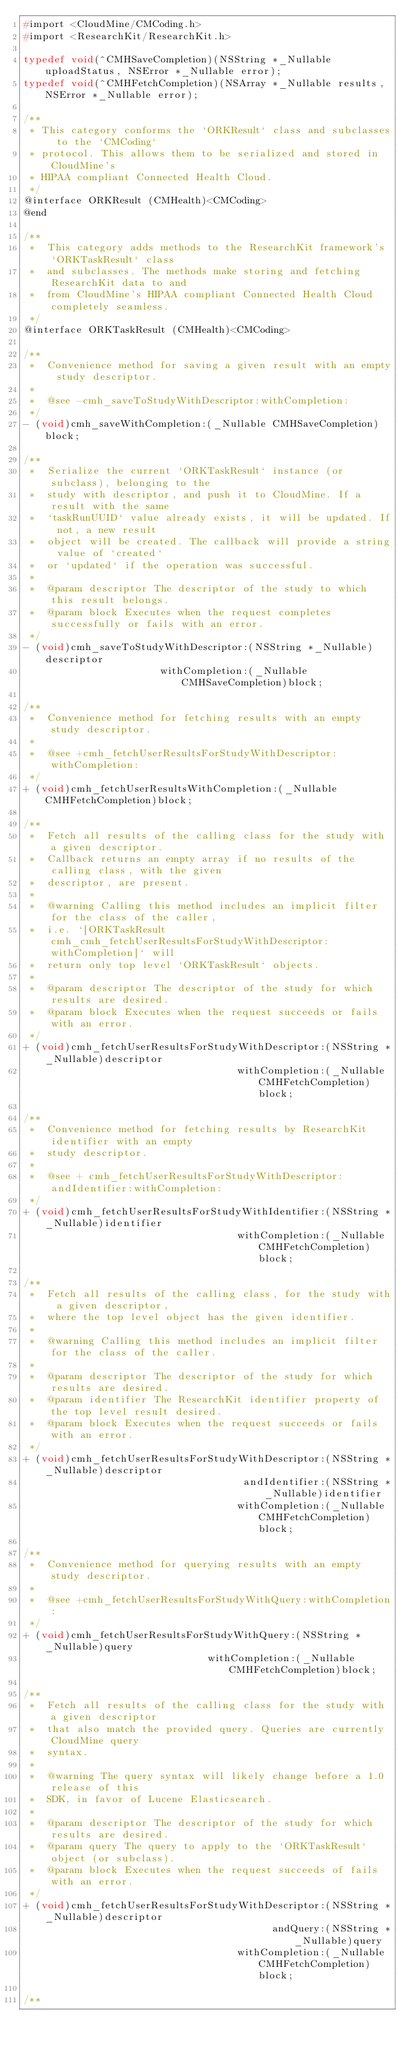Convert code to text. <code><loc_0><loc_0><loc_500><loc_500><_C_>#import <CloudMine/CMCoding.h>
#import <ResearchKit/ResearchKit.h>

typedef void(^CMHSaveCompletion)(NSString *_Nullable uploadStatus, NSError *_Nullable error);
typedef void(^CMHFetchCompletion)(NSArray *_Nullable results, NSError *_Nullable error);

/**
 * This category conforms the `ORKResult` class and subclasses to the `CMCoding`
 * protocol. This allows them to be serialized and stored in CloudMine's
 * HIPAA compliant Connected Health Cloud.
 */
@interface ORKResult (CMHealth)<CMCoding>
@end

/**
 *  This category adds methods to the ResearchKit framework's `ORKTaskResult` class 
 *  and subclasses. The methods make storing and fetching ResearchKit data to and
 *  from CloudMine's HIPAA compliant Connected Health Cloud completely seamless.
 */
@interface ORKTaskResult (CMHealth)<CMCoding>

/**
 *  Convenience method for saving a given result with an empty study descriptor.
 *
 *  @see -cmh_saveToStudyWithDescriptor:withCompletion:
 */
- (void)cmh_saveWithCompletion:(_Nullable CMHSaveCompletion)block;

/**
 *  Serialize the current `ORKTaskResult` instance (or subclass), belonging to the
 *  study with descriptor, and push it to CloudMine. If a result with the same
 *  `taskRunUUID` value already exists, it will be updated. If not, a new result
 *  object will be created. The callback will provide a string value of `created`
 *  or `updated` if the operation was successful.
 *
 *  @param descriptor The descriptor of the study to which this result belongs.
 *  @param block Executes when the request completes successfully or fails with an error.
 */
- (void)cmh_saveToStudyWithDescriptor:(NSString *_Nullable)descriptor
                       withCompletion:(_Nullable CMHSaveCompletion)block;

/**
 *  Convenience method for fetching results with an empty study descriptor.
 *
 *  @see +cmh_fetchUserResultsForStudyWithDescriptor:withCompletion:
 */
+ (void)cmh_fetchUserResultsWithCompletion:(_Nullable CMHFetchCompletion)block;

/**
 *  Fetch all results of the calling class for the study with a given descriptor.
 *  Callback returns an empty array if no results of the calling class, with the given
 *  descriptor, are present.
 *
 *  @warning Calling this method includes an implicit filter for the class of the caller,
 *  i.e. `[ORKTaskResult cmh_cmh_fetchUserResultsForStudyWithDescriptor:withCompletion]` will
 *  return only top level `ORKTaskResult` objects.
 *
 *  @param descriptor The descriptor of the study for which results are desired.
 *  @param block Executes when the request succeeds or fails with an error.
 */
+ (void)cmh_fetchUserResultsForStudyWithDescriptor:(NSString *_Nullable)descriptor
                                    withCompletion:(_Nullable CMHFetchCompletion)block;

/**
 *  Convenience method for fetching results by ResearchKit identifier with an empty
 *  study descriptor.
 *
 *  @see + cmh_fetchUserResultsForStudyWithDescriptor:andIdentifier:withCompletion:
 */
+ (void)cmh_fetchUserResultsForStudyWithIdentifier:(NSString *_Nullable)identifier
                                    withCompletion:(_Nullable CMHFetchCompletion)block;

/**
 *  Fetch all results of the calling class, for the study with a given descriptor,
 *  where the top level object has the given identifier.
 *
 *  @warning Calling this method includes an implicit filter for the class of the caller.
 *
 *  @param descriptor The descriptor of the study for which results are desired.
 *  @param identifier The ResearchKit identifier property of the top level result desired.
 *  @param block Executes when the request succeeds or fails with an error.
 */
+ (void)cmh_fetchUserResultsForStudyWithDescriptor:(NSString *_Nullable)descriptor
                                     andIdentifier:(NSString *_Nullable)identifier
                                    withCompletion:(_Nullable CMHFetchCompletion)block;

/**
 *  Convenience method for querying results with an empty study descriptor.
 *
 *  @see +cmh_fetchUserResultsForStudyWithQuery:withCompletion:
 */
+ (void)cmh_fetchUserResultsForStudyWithQuery:(NSString *_Nullable)query
                               withCompletion:(_Nullable CMHFetchCompletion)block;

/**
 *  Fetch all results of the calling class for the study with a given descriptor
 *  that also match the provided query. Queries are currently CloudMine query
 *  syntax.
 *
 *  @warning The query syntax will likely change before a 1.0 release of this
 *  SDK, in favor of Lucene Elasticsearch.
 *
 *  @param descriptor The descriptor of the study for which results are desired.
 *  @param query The query to apply to the `ORKTaskResult` object (or subclass).
 *  @param block Executes when the request succeeds of fails with an error.
 */
+ (void)cmh_fetchUserResultsForStudyWithDescriptor:(NSString *_Nullable)descriptor
                                          andQuery:(NSString *_Nullable)query
                                    withCompletion:(_Nullable CMHFetchCompletion)block;

/**</code> 